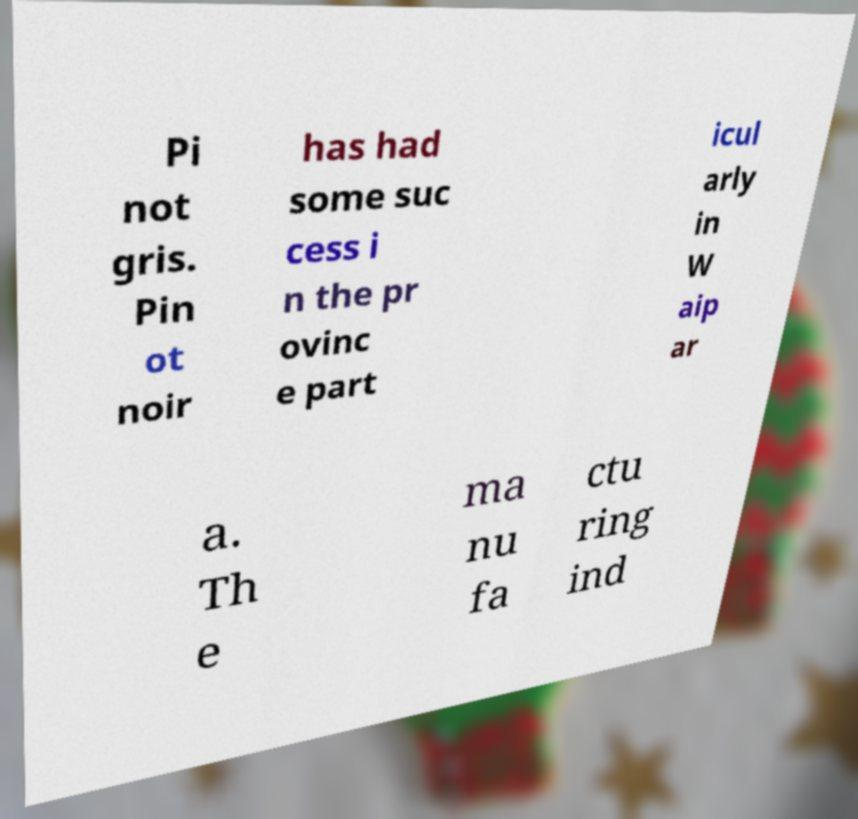For documentation purposes, I need the text within this image transcribed. Could you provide that? Pi not gris. Pin ot noir has had some suc cess i n the pr ovinc e part icul arly in W aip ar a. Th e ma nu fa ctu ring ind 